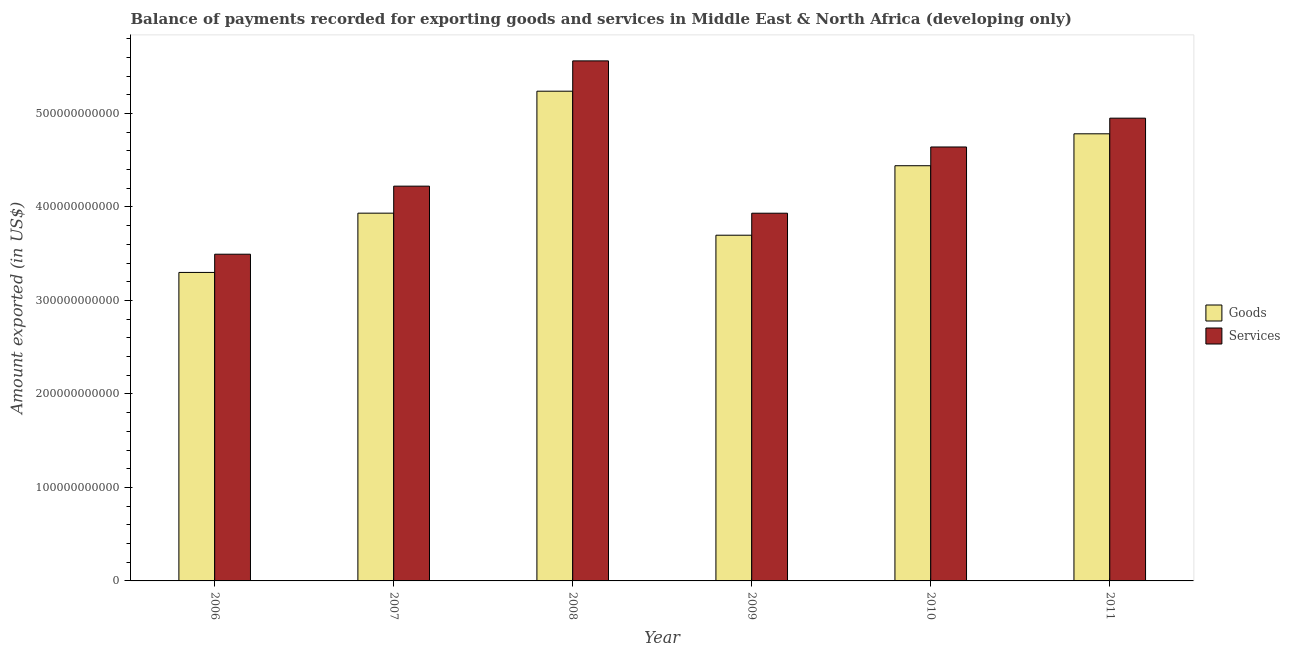Are the number of bars on each tick of the X-axis equal?
Offer a terse response. Yes. How many bars are there on the 5th tick from the right?
Provide a short and direct response. 2. What is the label of the 1st group of bars from the left?
Offer a very short reply. 2006. In how many cases, is the number of bars for a given year not equal to the number of legend labels?
Your answer should be compact. 0. What is the amount of goods exported in 2009?
Offer a very short reply. 3.70e+11. Across all years, what is the maximum amount of services exported?
Your answer should be compact. 5.56e+11. Across all years, what is the minimum amount of goods exported?
Your response must be concise. 3.30e+11. In which year was the amount of goods exported maximum?
Your answer should be very brief. 2008. In which year was the amount of goods exported minimum?
Offer a very short reply. 2006. What is the total amount of services exported in the graph?
Provide a short and direct response. 2.68e+12. What is the difference between the amount of goods exported in 2007 and that in 2009?
Make the answer very short. 2.36e+1. What is the difference between the amount of services exported in 2011 and the amount of goods exported in 2008?
Your answer should be compact. -6.13e+1. What is the average amount of services exported per year?
Your response must be concise. 4.47e+11. What is the ratio of the amount of services exported in 2006 to that in 2009?
Offer a terse response. 0.89. Is the amount of goods exported in 2007 less than that in 2010?
Your answer should be compact. Yes. What is the difference between the highest and the second highest amount of goods exported?
Offer a very short reply. 4.56e+1. What is the difference between the highest and the lowest amount of goods exported?
Provide a succinct answer. 1.94e+11. Is the sum of the amount of goods exported in 2006 and 2007 greater than the maximum amount of services exported across all years?
Your answer should be very brief. Yes. What does the 1st bar from the left in 2011 represents?
Offer a terse response. Goods. What does the 1st bar from the right in 2008 represents?
Give a very brief answer. Services. How many bars are there?
Offer a very short reply. 12. Are all the bars in the graph horizontal?
Keep it short and to the point. No. What is the difference between two consecutive major ticks on the Y-axis?
Offer a terse response. 1.00e+11. Are the values on the major ticks of Y-axis written in scientific E-notation?
Provide a succinct answer. No. Does the graph contain any zero values?
Provide a short and direct response. No. Does the graph contain grids?
Keep it short and to the point. No. How many legend labels are there?
Your response must be concise. 2. What is the title of the graph?
Keep it short and to the point. Balance of payments recorded for exporting goods and services in Middle East & North Africa (developing only). Does "By country of asylum" appear as one of the legend labels in the graph?
Provide a succinct answer. No. What is the label or title of the Y-axis?
Offer a very short reply. Amount exported (in US$). What is the Amount exported (in US$) of Goods in 2006?
Provide a succinct answer. 3.30e+11. What is the Amount exported (in US$) of Services in 2006?
Make the answer very short. 3.49e+11. What is the Amount exported (in US$) of Goods in 2007?
Ensure brevity in your answer.  3.93e+11. What is the Amount exported (in US$) of Services in 2007?
Provide a short and direct response. 4.22e+11. What is the Amount exported (in US$) in Goods in 2008?
Give a very brief answer. 5.24e+11. What is the Amount exported (in US$) of Services in 2008?
Your answer should be compact. 5.56e+11. What is the Amount exported (in US$) of Goods in 2009?
Your answer should be very brief. 3.70e+11. What is the Amount exported (in US$) in Services in 2009?
Keep it short and to the point. 3.93e+11. What is the Amount exported (in US$) of Goods in 2010?
Keep it short and to the point. 4.44e+11. What is the Amount exported (in US$) in Services in 2010?
Your answer should be very brief. 4.64e+11. What is the Amount exported (in US$) in Goods in 2011?
Your answer should be compact. 4.78e+11. What is the Amount exported (in US$) in Services in 2011?
Your answer should be very brief. 4.95e+11. Across all years, what is the maximum Amount exported (in US$) in Goods?
Your answer should be very brief. 5.24e+11. Across all years, what is the maximum Amount exported (in US$) of Services?
Your response must be concise. 5.56e+11. Across all years, what is the minimum Amount exported (in US$) in Goods?
Make the answer very short. 3.30e+11. Across all years, what is the minimum Amount exported (in US$) of Services?
Your answer should be very brief. 3.49e+11. What is the total Amount exported (in US$) of Goods in the graph?
Your answer should be very brief. 2.54e+12. What is the total Amount exported (in US$) in Services in the graph?
Provide a short and direct response. 2.68e+12. What is the difference between the Amount exported (in US$) of Goods in 2006 and that in 2007?
Your response must be concise. -6.34e+1. What is the difference between the Amount exported (in US$) in Services in 2006 and that in 2007?
Offer a very short reply. -7.28e+1. What is the difference between the Amount exported (in US$) in Goods in 2006 and that in 2008?
Your answer should be very brief. -1.94e+11. What is the difference between the Amount exported (in US$) of Services in 2006 and that in 2008?
Your answer should be very brief. -2.07e+11. What is the difference between the Amount exported (in US$) of Goods in 2006 and that in 2009?
Make the answer very short. -3.98e+1. What is the difference between the Amount exported (in US$) in Services in 2006 and that in 2009?
Your response must be concise. -4.38e+1. What is the difference between the Amount exported (in US$) of Goods in 2006 and that in 2010?
Offer a very short reply. -1.14e+11. What is the difference between the Amount exported (in US$) in Services in 2006 and that in 2010?
Keep it short and to the point. -1.15e+11. What is the difference between the Amount exported (in US$) of Goods in 2006 and that in 2011?
Offer a terse response. -1.48e+11. What is the difference between the Amount exported (in US$) of Services in 2006 and that in 2011?
Your answer should be very brief. -1.46e+11. What is the difference between the Amount exported (in US$) in Goods in 2007 and that in 2008?
Provide a succinct answer. -1.30e+11. What is the difference between the Amount exported (in US$) of Services in 2007 and that in 2008?
Offer a terse response. -1.34e+11. What is the difference between the Amount exported (in US$) in Goods in 2007 and that in 2009?
Keep it short and to the point. 2.36e+1. What is the difference between the Amount exported (in US$) of Services in 2007 and that in 2009?
Offer a very short reply. 2.89e+1. What is the difference between the Amount exported (in US$) in Goods in 2007 and that in 2010?
Make the answer very short. -5.07e+1. What is the difference between the Amount exported (in US$) in Services in 2007 and that in 2010?
Make the answer very short. -4.19e+1. What is the difference between the Amount exported (in US$) in Goods in 2007 and that in 2011?
Provide a succinct answer. -8.49e+1. What is the difference between the Amount exported (in US$) in Services in 2007 and that in 2011?
Your answer should be compact. -7.27e+1. What is the difference between the Amount exported (in US$) of Goods in 2008 and that in 2009?
Offer a terse response. 1.54e+11. What is the difference between the Amount exported (in US$) of Services in 2008 and that in 2009?
Keep it short and to the point. 1.63e+11. What is the difference between the Amount exported (in US$) of Goods in 2008 and that in 2010?
Offer a very short reply. 7.97e+1. What is the difference between the Amount exported (in US$) in Services in 2008 and that in 2010?
Ensure brevity in your answer.  9.21e+1. What is the difference between the Amount exported (in US$) of Goods in 2008 and that in 2011?
Your answer should be compact. 4.56e+1. What is the difference between the Amount exported (in US$) in Services in 2008 and that in 2011?
Make the answer very short. 6.13e+1. What is the difference between the Amount exported (in US$) of Goods in 2009 and that in 2010?
Your response must be concise. -7.43e+1. What is the difference between the Amount exported (in US$) of Services in 2009 and that in 2010?
Give a very brief answer. -7.08e+1. What is the difference between the Amount exported (in US$) of Goods in 2009 and that in 2011?
Your response must be concise. -1.08e+11. What is the difference between the Amount exported (in US$) of Services in 2009 and that in 2011?
Your response must be concise. -1.02e+11. What is the difference between the Amount exported (in US$) in Goods in 2010 and that in 2011?
Offer a very short reply. -3.41e+1. What is the difference between the Amount exported (in US$) in Services in 2010 and that in 2011?
Provide a succinct answer. -3.08e+1. What is the difference between the Amount exported (in US$) in Goods in 2006 and the Amount exported (in US$) in Services in 2007?
Make the answer very short. -9.23e+1. What is the difference between the Amount exported (in US$) in Goods in 2006 and the Amount exported (in US$) in Services in 2008?
Provide a succinct answer. -2.26e+11. What is the difference between the Amount exported (in US$) in Goods in 2006 and the Amount exported (in US$) in Services in 2009?
Keep it short and to the point. -6.33e+1. What is the difference between the Amount exported (in US$) of Goods in 2006 and the Amount exported (in US$) of Services in 2010?
Your answer should be very brief. -1.34e+11. What is the difference between the Amount exported (in US$) in Goods in 2006 and the Amount exported (in US$) in Services in 2011?
Offer a very short reply. -1.65e+11. What is the difference between the Amount exported (in US$) of Goods in 2007 and the Amount exported (in US$) of Services in 2008?
Your response must be concise. -1.63e+11. What is the difference between the Amount exported (in US$) of Goods in 2007 and the Amount exported (in US$) of Services in 2009?
Give a very brief answer. 5.07e+07. What is the difference between the Amount exported (in US$) of Goods in 2007 and the Amount exported (in US$) of Services in 2010?
Offer a very short reply. -7.08e+1. What is the difference between the Amount exported (in US$) in Goods in 2007 and the Amount exported (in US$) in Services in 2011?
Your response must be concise. -1.02e+11. What is the difference between the Amount exported (in US$) in Goods in 2008 and the Amount exported (in US$) in Services in 2009?
Your answer should be very brief. 1.30e+11. What is the difference between the Amount exported (in US$) in Goods in 2008 and the Amount exported (in US$) in Services in 2010?
Offer a terse response. 5.97e+1. What is the difference between the Amount exported (in US$) in Goods in 2008 and the Amount exported (in US$) in Services in 2011?
Your answer should be very brief. 2.88e+1. What is the difference between the Amount exported (in US$) of Goods in 2009 and the Amount exported (in US$) of Services in 2010?
Give a very brief answer. -9.44e+1. What is the difference between the Amount exported (in US$) of Goods in 2009 and the Amount exported (in US$) of Services in 2011?
Provide a short and direct response. -1.25e+11. What is the difference between the Amount exported (in US$) of Goods in 2010 and the Amount exported (in US$) of Services in 2011?
Provide a short and direct response. -5.09e+1. What is the average Amount exported (in US$) of Goods per year?
Provide a succinct answer. 4.23e+11. What is the average Amount exported (in US$) in Services per year?
Offer a terse response. 4.47e+11. In the year 2006, what is the difference between the Amount exported (in US$) of Goods and Amount exported (in US$) of Services?
Give a very brief answer. -1.95e+1. In the year 2007, what is the difference between the Amount exported (in US$) of Goods and Amount exported (in US$) of Services?
Provide a short and direct response. -2.89e+1. In the year 2008, what is the difference between the Amount exported (in US$) of Goods and Amount exported (in US$) of Services?
Ensure brevity in your answer.  -3.24e+1. In the year 2009, what is the difference between the Amount exported (in US$) in Goods and Amount exported (in US$) in Services?
Make the answer very short. -2.35e+1. In the year 2010, what is the difference between the Amount exported (in US$) of Goods and Amount exported (in US$) of Services?
Make the answer very short. -2.00e+1. In the year 2011, what is the difference between the Amount exported (in US$) in Goods and Amount exported (in US$) in Services?
Offer a terse response. -1.67e+1. What is the ratio of the Amount exported (in US$) in Goods in 2006 to that in 2007?
Make the answer very short. 0.84. What is the ratio of the Amount exported (in US$) of Services in 2006 to that in 2007?
Make the answer very short. 0.83. What is the ratio of the Amount exported (in US$) of Goods in 2006 to that in 2008?
Provide a succinct answer. 0.63. What is the ratio of the Amount exported (in US$) of Services in 2006 to that in 2008?
Offer a terse response. 0.63. What is the ratio of the Amount exported (in US$) in Goods in 2006 to that in 2009?
Give a very brief answer. 0.89. What is the ratio of the Amount exported (in US$) in Services in 2006 to that in 2009?
Provide a succinct answer. 0.89. What is the ratio of the Amount exported (in US$) in Goods in 2006 to that in 2010?
Provide a short and direct response. 0.74. What is the ratio of the Amount exported (in US$) in Services in 2006 to that in 2010?
Keep it short and to the point. 0.75. What is the ratio of the Amount exported (in US$) of Goods in 2006 to that in 2011?
Keep it short and to the point. 0.69. What is the ratio of the Amount exported (in US$) of Services in 2006 to that in 2011?
Offer a very short reply. 0.71. What is the ratio of the Amount exported (in US$) of Goods in 2007 to that in 2008?
Offer a terse response. 0.75. What is the ratio of the Amount exported (in US$) of Services in 2007 to that in 2008?
Your response must be concise. 0.76. What is the ratio of the Amount exported (in US$) of Goods in 2007 to that in 2009?
Ensure brevity in your answer.  1.06. What is the ratio of the Amount exported (in US$) in Services in 2007 to that in 2009?
Provide a short and direct response. 1.07. What is the ratio of the Amount exported (in US$) in Goods in 2007 to that in 2010?
Give a very brief answer. 0.89. What is the ratio of the Amount exported (in US$) of Services in 2007 to that in 2010?
Keep it short and to the point. 0.91. What is the ratio of the Amount exported (in US$) in Goods in 2007 to that in 2011?
Make the answer very short. 0.82. What is the ratio of the Amount exported (in US$) of Services in 2007 to that in 2011?
Offer a very short reply. 0.85. What is the ratio of the Amount exported (in US$) of Goods in 2008 to that in 2009?
Your answer should be very brief. 1.42. What is the ratio of the Amount exported (in US$) in Services in 2008 to that in 2009?
Offer a terse response. 1.41. What is the ratio of the Amount exported (in US$) in Goods in 2008 to that in 2010?
Your answer should be compact. 1.18. What is the ratio of the Amount exported (in US$) of Services in 2008 to that in 2010?
Provide a short and direct response. 1.2. What is the ratio of the Amount exported (in US$) of Goods in 2008 to that in 2011?
Provide a short and direct response. 1.1. What is the ratio of the Amount exported (in US$) in Services in 2008 to that in 2011?
Offer a very short reply. 1.12. What is the ratio of the Amount exported (in US$) in Goods in 2009 to that in 2010?
Your response must be concise. 0.83. What is the ratio of the Amount exported (in US$) of Services in 2009 to that in 2010?
Offer a terse response. 0.85. What is the ratio of the Amount exported (in US$) in Goods in 2009 to that in 2011?
Your response must be concise. 0.77. What is the ratio of the Amount exported (in US$) in Services in 2009 to that in 2011?
Keep it short and to the point. 0.79. What is the ratio of the Amount exported (in US$) in Goods in 2010 to that in 2011?
Provide a short and direct response. 0.93. What is the ratio of the Amount exported (in US$) in Services in 2010 to that in 2011?
Give a very brief answer. 0.94. What is the difference between the highest and the second highest Amount exported (in US$) of Goods?
Offer a very short reply. 4.56e+1. What is the difference between the highest and the second highest Amount exported (in US$) of Services?
Ensure brevity in your answer.  6.13e+1. What is the difference between the highest and the lowest Amount exported (in US$) of Goods?
Your answer should be very brief. 1.94e+11. What is the difference between the highest and the lowest Amount exported (in US$) of Services?
Offer a terse response. 2.07e+11. 